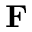<formula> <loc_0><loc_0><loc_500><loc_500>{ F }</formula> 